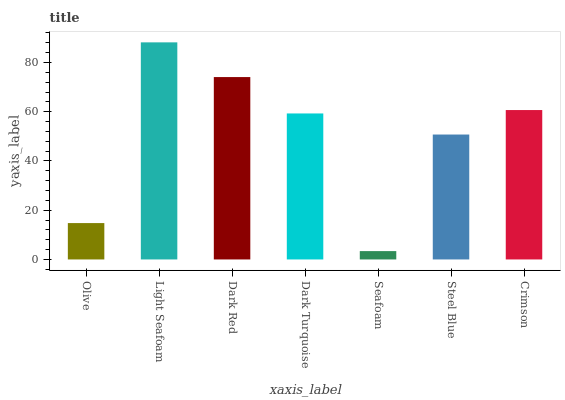Is Seafoam the minimum?
Answer yes or no. Yes. Is Light Seafoam the maximum?
Answer yes or no. Yes. Is Dark Red the minimum?
Answer yes or no. No. Is Dark Red the maximum?
Answer yes or no. No. Is Light Seafoam greater than Dark Red?
Answer yes or no. Yes. Is Dark Red less than Light Seafoam?
Answer yes or no. Yes. Is Dark Red greater than Light Seafoam?
Answer yes or no. No. Is Light Seafoam less than Dark Red?
Answer yes or no. No. Is Dark Turquoise the high median?
Answer yes or no. Yes. Is Dark Turquoise the low median?
Answer yes or no. Yes. Is Steel Blue the high median?
Answer yes or no. No. Is Crimson the low median?
Answer yes or no. No. 